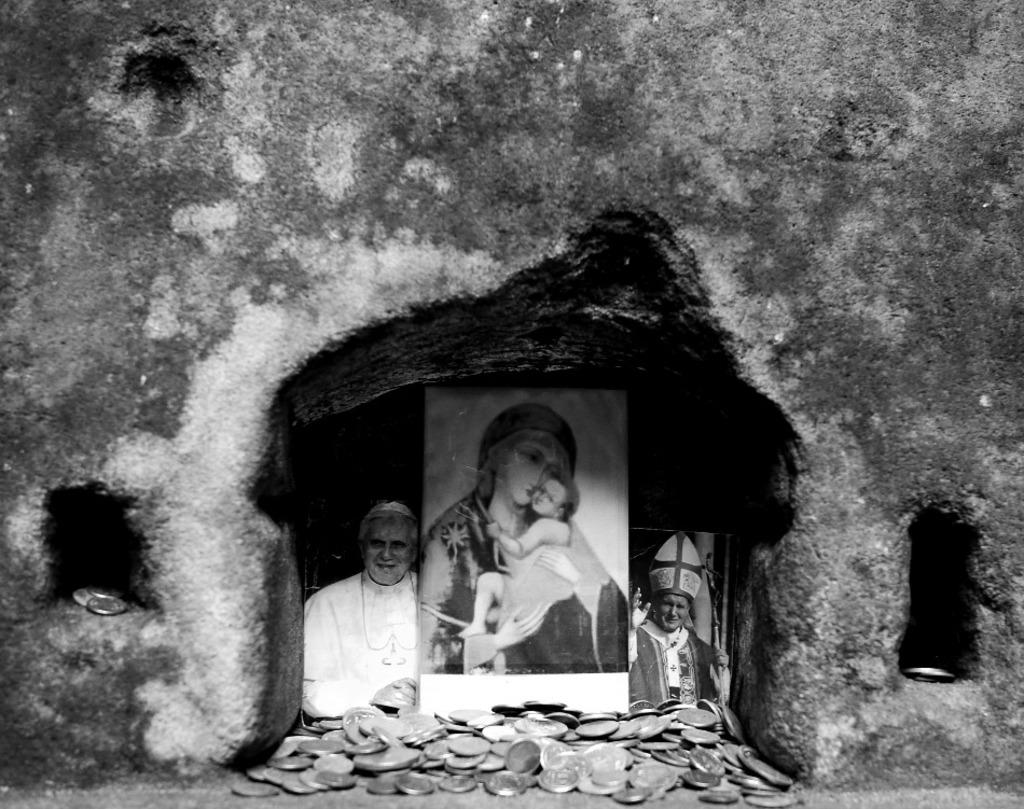What is the color scheme of the image? The image is black and white. What can be seen in the center of the image? There are photo frames and coins in the wall in the center of the image. What type of print is visible on the coins in the image? There is no print visible on the coins in the image, as the image is in black and white and does not show any details on the coins. What type of vessel is used to store the coins in the image? There is no vessel present in the image; the coins are embedded in the wall. 